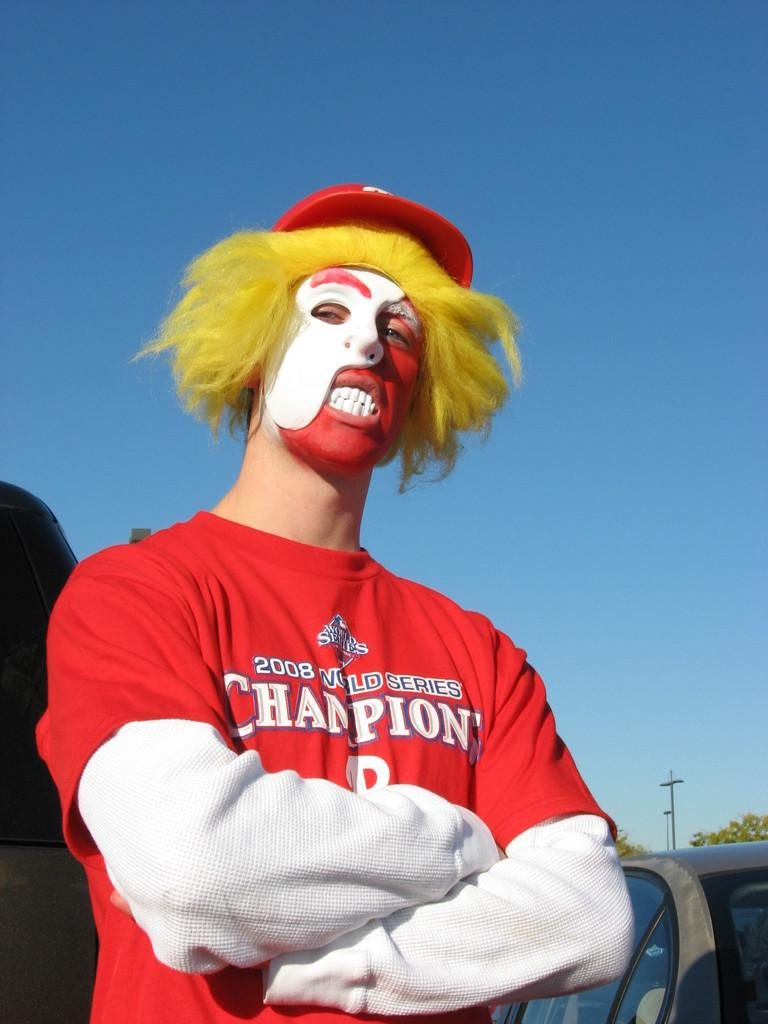<image>
Write a terse but informative summary of the picture. A man dressed up like a clown wears a red shirt that says "2008 World Series Champions." 